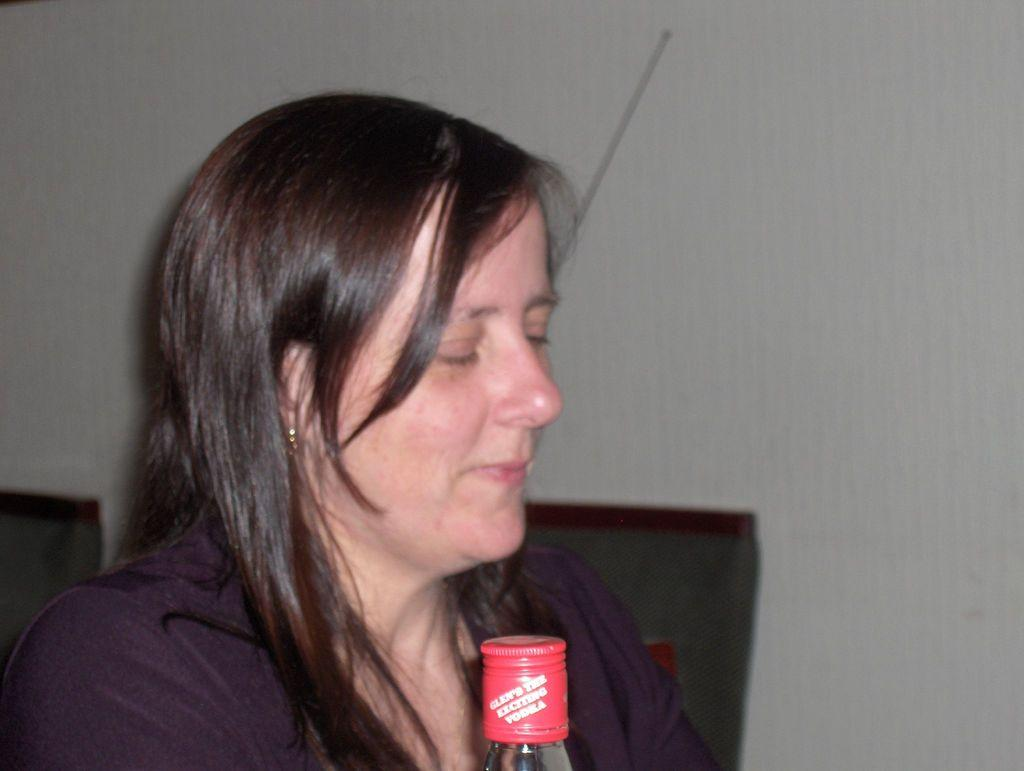What is present in the image along with the person? There is a bottle in the image. Can you describe the background of the image? There are objects and a wall in the background of the image. What type of eggnog can be seen in the person's hand in the image? There is no eggnog present in the image; it only shows a person and a bottle. Can you describe the person running in the image? There is no person running in the image; the person is standing or holding something. 